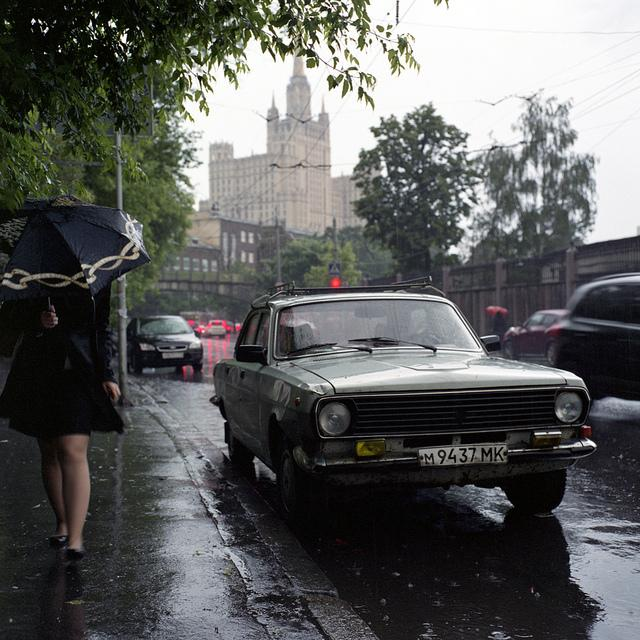What is the danger faced by the woman on the left? car 